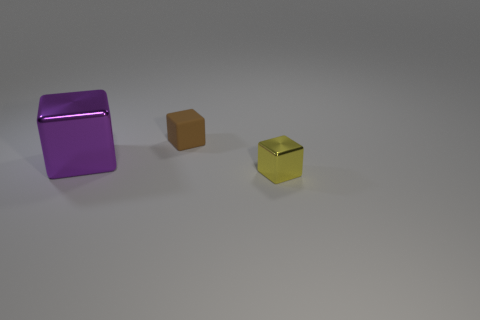There is a small brown thing that is the same shape as the small yellow metal object; what material is it?
Your answer should be compact. Rubber. There is a yellow thing that is the same size as the brown thing; what material is it?
Give a very brief answer. Metal. Is there a brown rubber thing that has the same size as the yellow shiny block?
Your answer should be compact. Yes. Are there the same number of small yellow metallic blocks to the left of the purple object and big metallic blocks that are behind the tiny metallic object?
Make the answer very short. No. Is the number of brown cubes greater than the number of tiny red shiny spheres?
Provide a short and direct response. Yes. How many shiny things are either tiny gray blocks or purple objects?
Your answer should be very brief. 1. What number of cubes are the same color as the matte thing?
Provide a succinct answer. 0. There is a tiny object in front of the tiny block behind the metallic cube on the left side of the matte cube; what is its material?
Provide a succinct answer. Metal. There is a cube left of the small object left of the yellow shiny object; what is its color?
Your answer should be very brief. Purple. How many tiny objects are yellow blocks or brown blocks?
Make the answer very short. 2. 